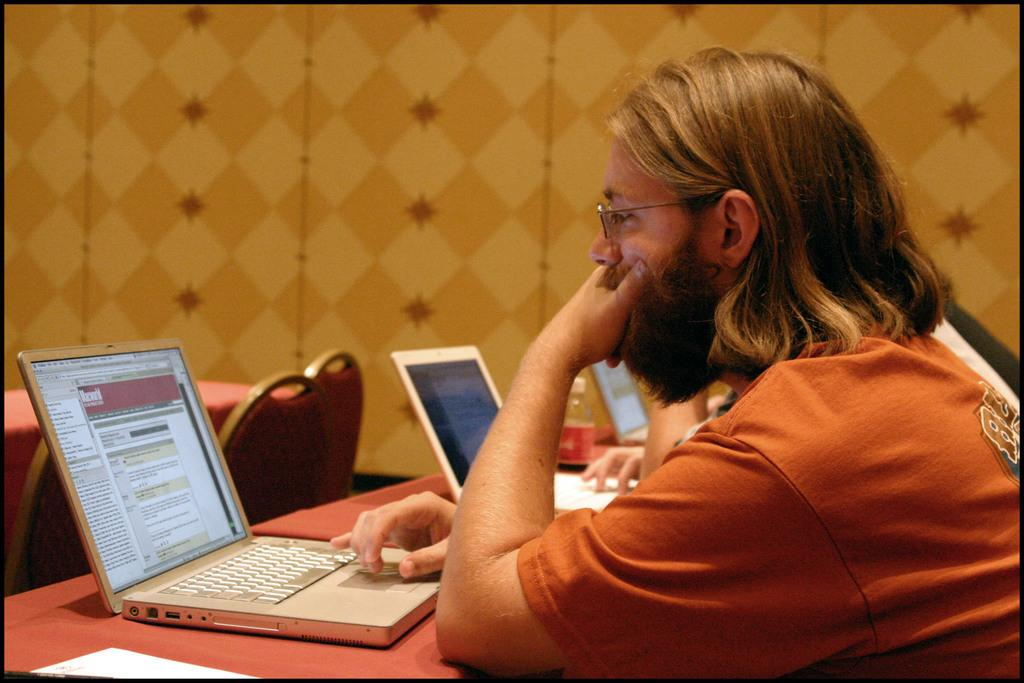What is the person in the image doing? The person is looking at a laptop screen. What object is the person likely using to interact with the laptop? A human hand and fingers are visible in the image, which suggests the person is using their hand to interact with the laptop. What can be seen on the table in the image? There is a bottle and a laptop on the table in the image. What type of furniture is present in the image? Chairs and tables are visible in the image. What is the background of the image? There is a wall in the image. What type of secretary is present in the image? There is no secretary present in the image; it only shows a person looking at a laptop screen. What type of nut can be seen in the image? There is no nut present in the image. 